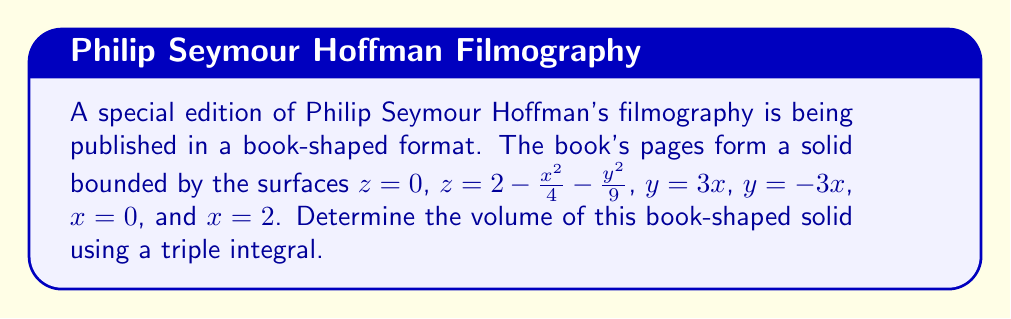Teach me how to tackle this problem. To find the volume of the book-shaped solid, we need to set up and evaluate a triple integral. Let's approach this step-by-step:

1) The bounds of the integral:
   - $x$ ranges from 0 to 2
   - $y$ is bounded by $-3x$ and $3x$
   - $z$ ranges from 0 to $2 - \frac{x^2}{4} - \frac{y^2}{9}$

2) Set up the triple integral:

   $$V = \int_0^2 \int_{-3x}^{3x} \int_0^{2 - \frac{x^2}{4} - \frac{y^2}{9}} dz \, dy \, dx$$

3) Evaluate the innermost integral (with respect to $z$):

   $$V = \int_0^2 \int_{-3x}^{3x} \left[2 - \frac{x^2}{4} - \frac{y^2}{9}\right] dy \, dx$$

4) Evaluate the integral with respect to $y$:

   $$V = \int_0^2 \left[2y - \frac{x^2}{4}y - \frac{y^3}{27}\right]_{-3x}^{3x} dx$$
   
   $$V = \int_0^2 \left[(6x - \frac{3x^3}{4} - \frac{27x^3}{27}) - (-6x - \frac{3x^3}{4} + \frac{27x^3}{27})\right] dx$$
   
   $$V = \int_0^2 \left[12x - \frac{54x^3}{27}\right] dx$$

5) Simplify:

   $$V = \int_0^2 \left[12x - 2x^3\right] dx$$

6) Evaluate the final integral:

   $$V = \left[6x^2 - \frac{1}{2}x^4\right]_0^2$$
   
   $$V = \left(24 - 8\right) - \left(0 - 0\right) = 16$$

Therefore, the volume of the book-shaped solid is 16 cubic units.
Answer: $16$ cubic units 